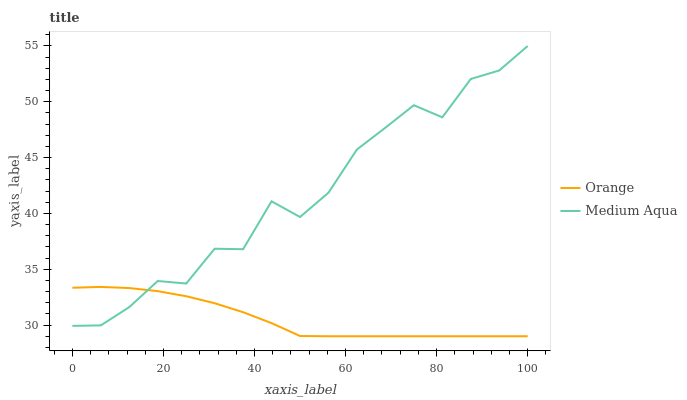Does Orange have the minimum area under the curve?
Answer yes or no. Yes. Does Medium Aqua have the maximum area under the curve?
Answer yes or no. Yes. Does Medium Aqua have the minimum area under the curve?
Answer yes or no. No. Is Orange the smoothest?
Answer yes or no. Yes. Is Medium Aqua the roughest?
Answer yes or no. Yes. Is Medium Aqua the smoothest?
Answer yes or no. No. Does Medium Aqua have the lowest value?
Answer yes or no. No. Does Medium Aqua have the highest value?
Answer yes or no. Yes. Does Orange intersect Medium Aqua?
Answer yes or no. Yes. Is Orange less than Medium Aqua?
Answer yes or no. No. Is Orange greater than Medium Aqua?
Answer yes or no. No. 